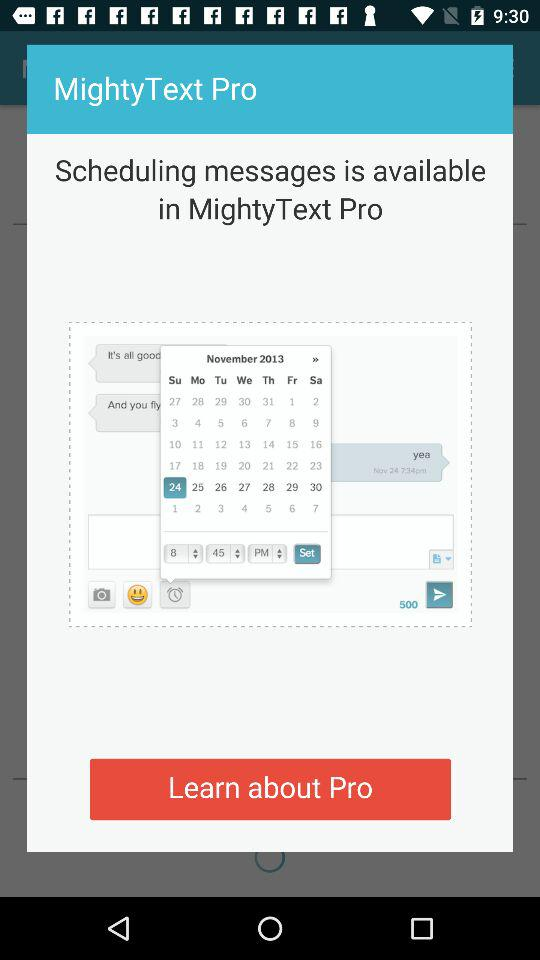Which date is selected on the calendar? The selected date is Sunday, November 24, 2013. 